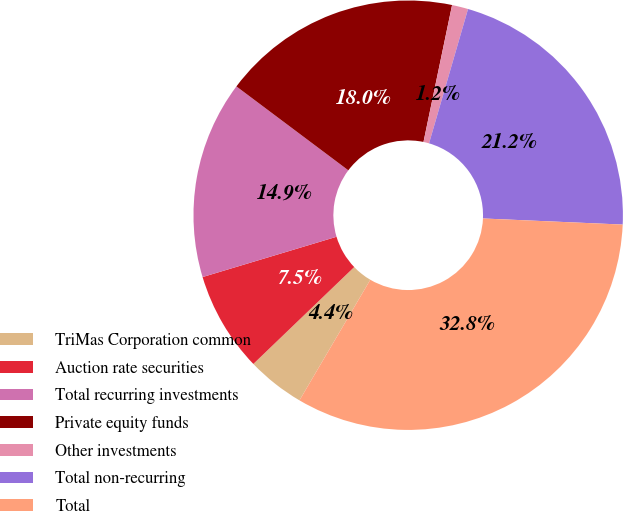Convert chart. <chart><loc_0><loc_0><loc_500><loc_500><pie_chart><fcel>TriMas Corporation common<fcel>Auction rate securities<fcel>Total recurring investments<fcel>Private equity funds<fcel>Other investments<fcel>Total non-recurring<fcel>Total<nl><fcel>4.37%<fcel>7.53%<fcel>14.89%<fcel>18.04%<fcel>1.22%<fcel>21.2%<fcel>32.76%<nl></chart> 